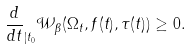Convert formula to latex. <formula><loc_0><loc_0><loc_500><loc_500>\frac { d } { d t } _ { | { t _ { 0 } } } \mathcal { W } _ { \beta } ( \Omega _ { t } , f ( t ) , \tau ( t ) ) \geq 0 .</formula> 